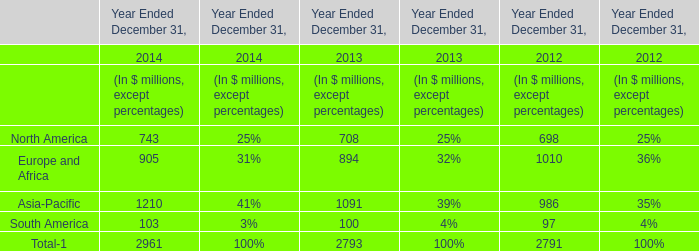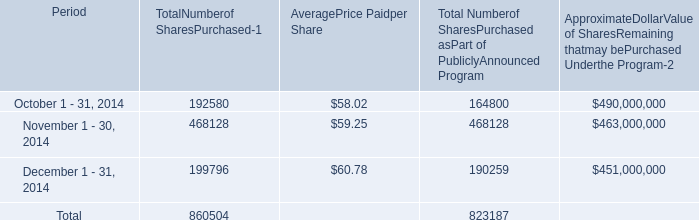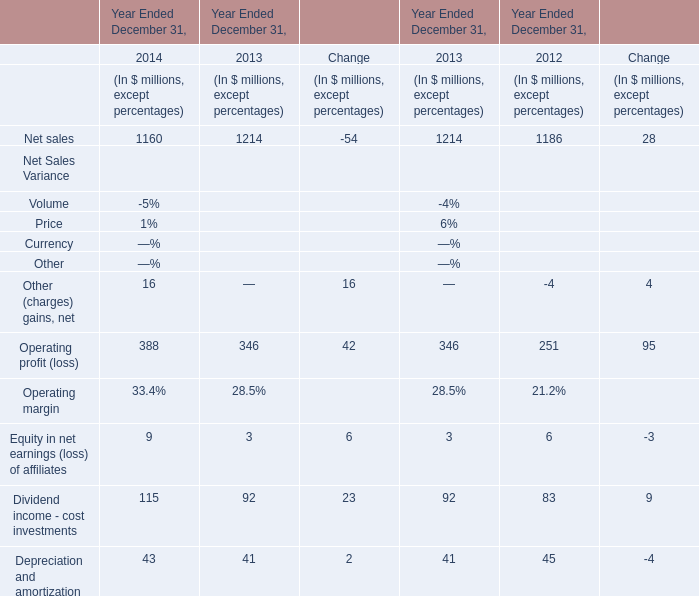What's the growth rate of net sales in 2014? (in %) 
Computations: ((1160 - 1214) / 1160)
Answer: -0.04655. 